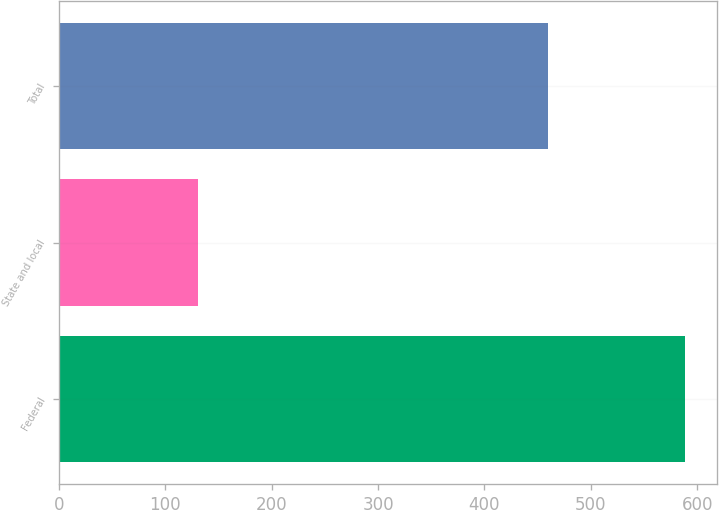Convert chart to OTSL. <chart><loc_0><loc_0><loc_500><loc_500><bar_chart><fcel>Federal<fcel>State and local<fcel>Total<nl><fcel>589<fcel>131<fcel>460<nl></chart> 